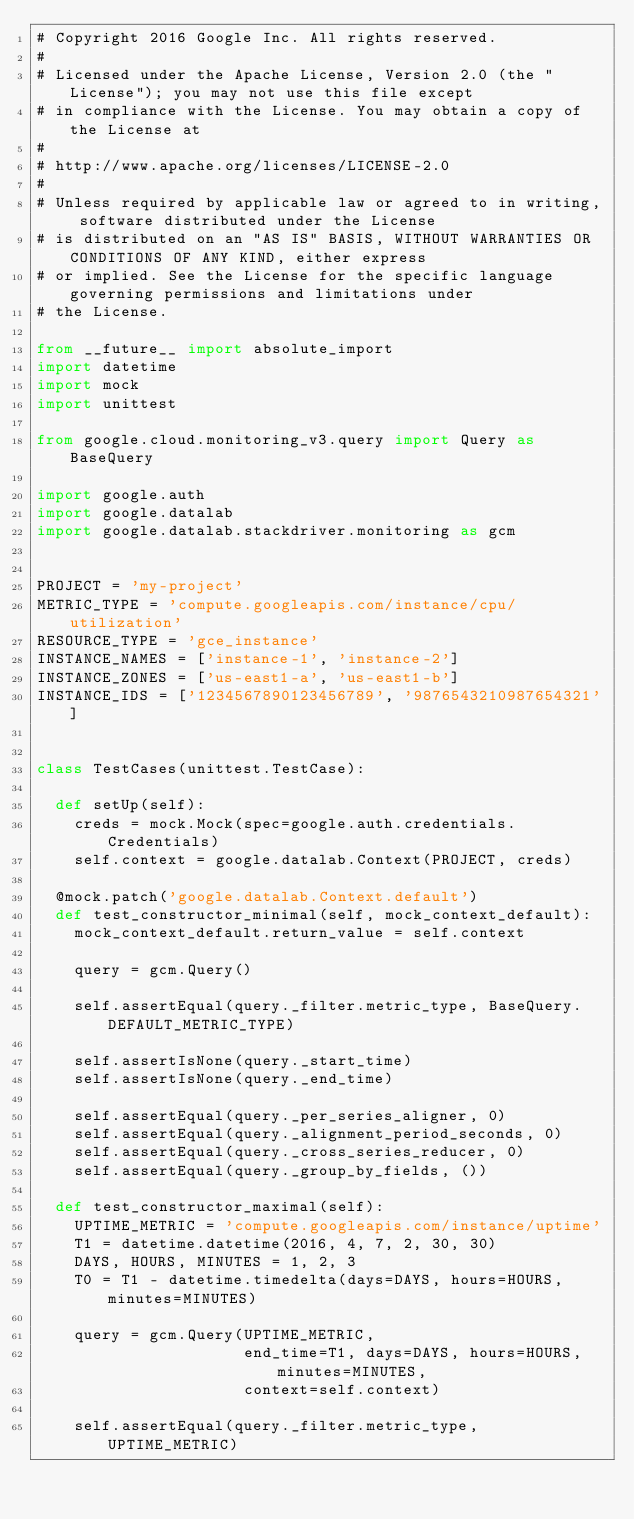<code> <loc_0><loc_0><loc_500><loc_500><_Python_># Copyright 2016 Google Inc. All rights reserved.
#
# Licensed under the Apache License, Version 2.0 (the "License"); you may not use this file except
# in compliance with the License. You may obtain a copy of the License at
#
# http://www.apache.org/licenses/LICENSE-2.0
#
# Unless required by applicable law or agreed to in writing, software distributed under the License
# is distributed on an "AS IS" BASIS, WITHOUT WARRANTIES OR CONDITIONS OF ANY KIND, either express
# or implied. See the License for the specific language governing permissions and limitations under
# the License.

from __future__ import absolute_import
import datetime
import mock
import unittest

from google.cloud.monitoring_v3.query import Query as BaseQuery

import google.auth
import google.datalab
import google.datalab.stackdriver.monitoring as gcm


PROJECT = 'my-project'
METRIC_TYPE = 'compute.googleapis.com/instance/cpu/utilization'
RESOURCE_TYPE = 'gce_instance'
INSTANCE_NAMES = ['instance-1', 'instance-2']
INSTANCE_ZONES = ['us-east1-a', 'us-east1-b']
INSTANCE_IDS = ['1234567890123456789', '9876543210987654321']


class TestCases(unittest.TestCase):

  def setUp(self):
    creds = mock.Mock(spec=google.auth.credentials.Credentials)
    self.context = google.datalab.Context(PROJECT, creds)

  @mock.patch('google.datalab.Context.default')
  def test_constructor_minimal(self, mock_context_default):
    mock_context_default.return_value = self.context

    query = gcm.Query()

    self.assertEqual(query._filter.metric_type, BaseQuery.DEFAULT_METRIC_TYPE)

    self.assertIsNone(query._start_time)
    self.assertIsNone(query._end_time)

    self.assertEqual(query._per_series_aligner, 0)
    self.assertEqual(query._alignment_period_seconds, 0)
    self.assertEqual(query._cross_series_reducer, 0)
    self.assertEqual(query._group_by_fields, ())

  def test_constructor_maximal(self):
    UPTIME_METRIC = 'compute.googleapis.com/instance/uptime'
    T1 = datetime.datetime(2016, 4, 7, 2, 30, 30)
    DAYS, HOURS, MINUTES = 1, 2, 3
    T0 = T1 - datetime.timedelta(days=DAYS, hours=HOURS, minutes=MINUTES)

    query = gcm.Query(UPTIME_METRIC,
                      end_time=T1, days=DAYS, hours=HOURS, minutes=MINUTES,
                      context=self.context)

    self.assertEqual(query._filter.metric_type, UPTIME_METRIC)
</code> 